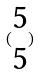Convert formula to latex. <formula><loc_0><loc_0><loc_500><loc_500>( \begin{matrix} 5 \\ 5 \end{matrix} )</formula> 